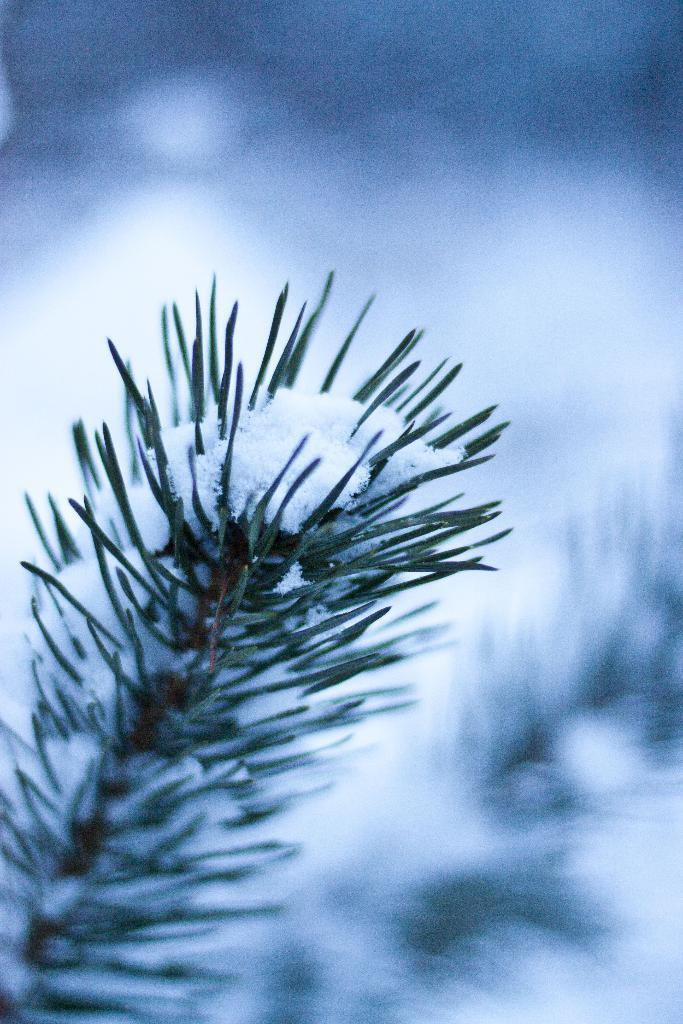What type of vegetation is visible in the front of the image? There is grass in the front of the image. What is covering the grass in the image? There is snow on the grass. Can you describe the background of the image? The background of the image is blurry. What type of door can be seen in the image? There is no door present in the image; it features grass with snow on it and a blurry background. 